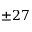Convert formula to latex. <formula><loc_0><loc_0><loc_500><loc_500>\pm 2 7</formula> 